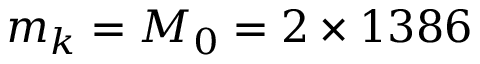<formula> <loc_0><loc_0><loc_500><loc_500>m _ { k } = M _ { 0 } = 2 \times 1 3 8 6</formula> 